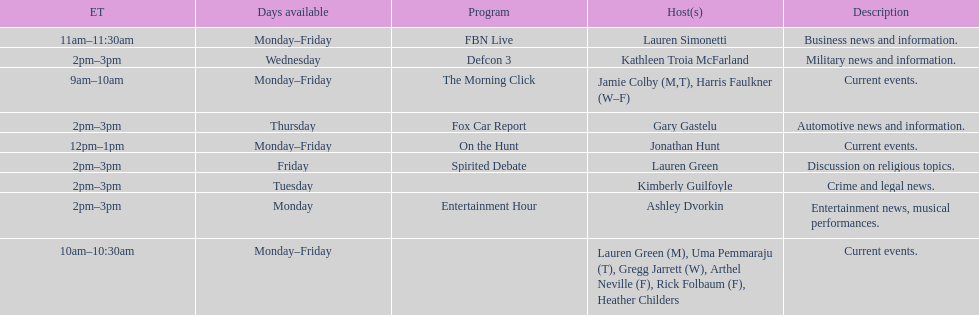How long does the show defcon 3 last? 1 hour. 